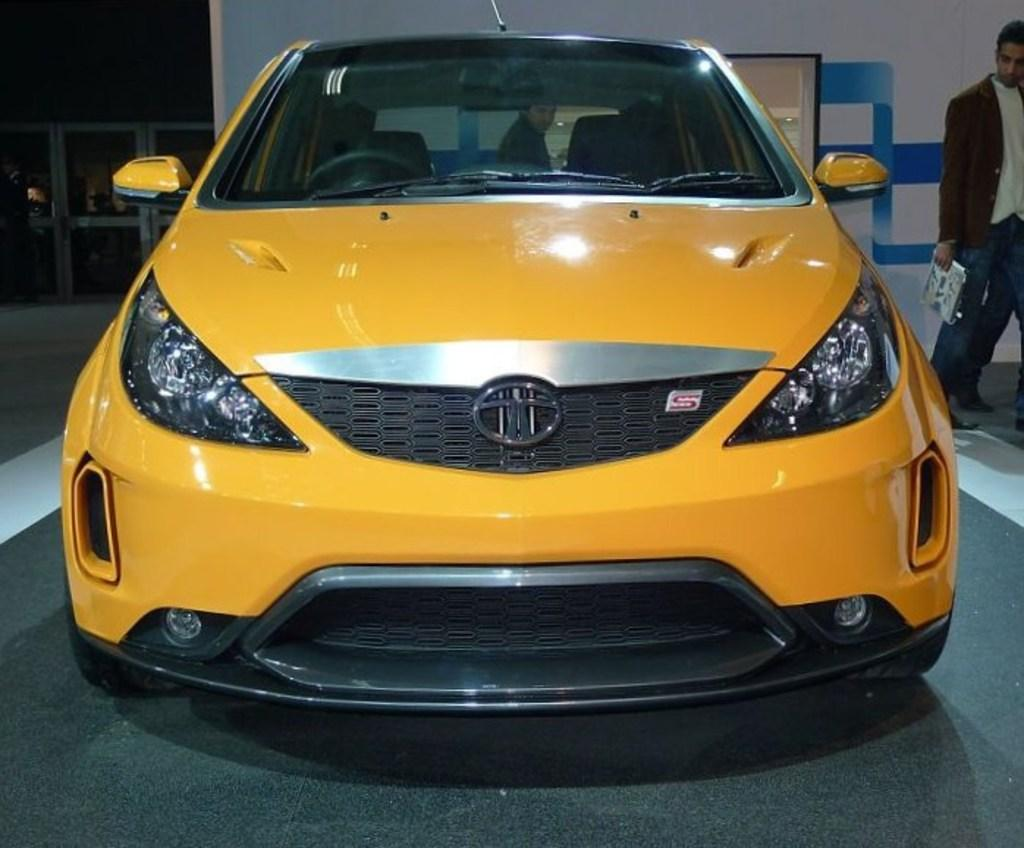What type of vehicle is in the showroom? There is a car in the showroom. What color is the car? The car is orange in color. Who is present in the image besides the car? There is a man standing in the image. What is the man holding in his hand? The man is holding papers in his hand. What can be seen in the background of the image? There is a wall visible in the background of the image. How does the man show his grip on the car in the image? The man is not shown gripping the car in the image; he is holding papers. 